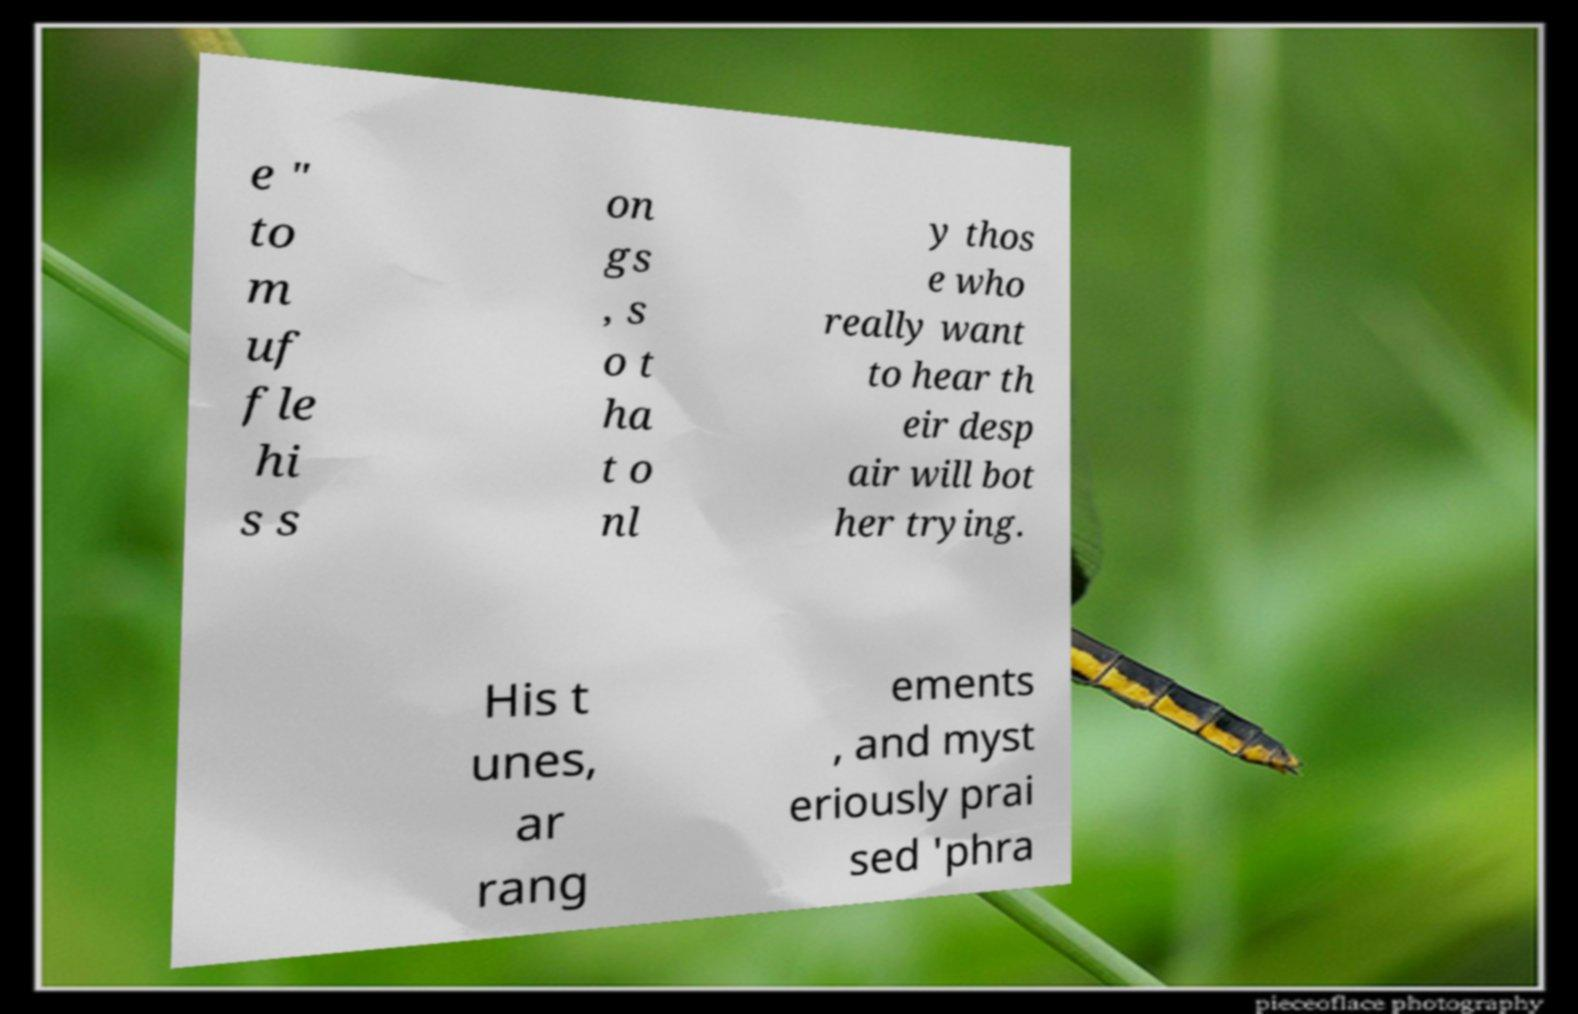What messages or text are displayed in this image? I need them in a readable, typed format. e " to m uf fle hi s s on gs , s o t ha t o nl y thos e who really want to hear th eir desp air will bot her trying. His t unes, ar rang ements , and myst eriously prai sed 'phra 